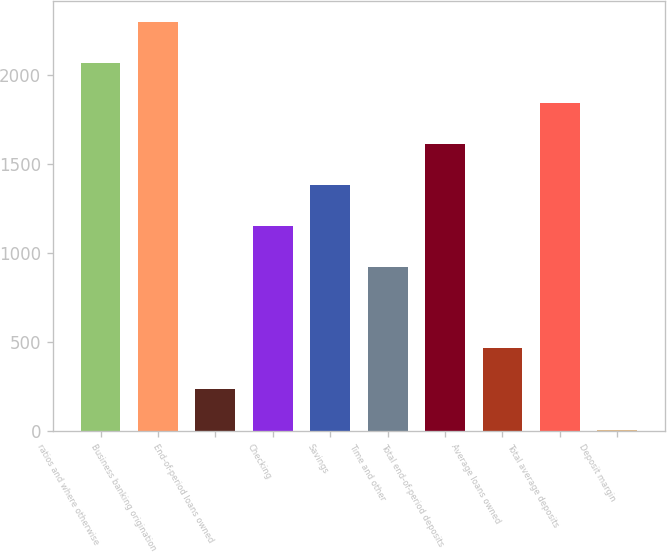Convert chart to OTSL. <chart><loc_0><loc_0><loc_500><loc_500><bar_chart><fcel>ratios and where otherwise<fcel>Business banking origination<fcel>End-of-period loans owned<fcel>Checking<fcel>Savings<fcel>Time and other<fcel>Total end-of-period deposits<fcel>Average loans owned<fcel>Total average deposits<fcel>Deposit margin<nl><fcel>2069.36<fcel>2299<fcel>232.56<fcel>1150.96<fcel>1380.56<fcel>921.36<fcel>1610.16<fcel>462.16<fcel>1839.76<fcel>2.96<nl></chart> 